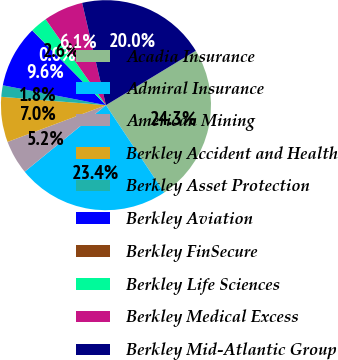Convert chart to OTSL. <chart><loc_0><loc_0><loc_500><loc_500><pie_chart><fcel>Acadia Insurance<fcel>Admiral Insurance<fcel>American Mining<fcel>Berkley Accident and Health<fcel>Berkley Asset Protection<fcel>Berkley Aviation<fcel>Berkley FinSecure<fcel>Berkley Life Sciences<fcel>Berkley Medical Excess<fcel>Berkley Mid-Atlantic Group<nl><fcel>24.31%<fcel>23.44%<fcel>5.23%<fcel>6.96%<fcel>1.76%<fcel>9.57%<fcel>0.03%<fcel>2.63%<fcel>6.1%<fcel>19.97%<nl></chart> 